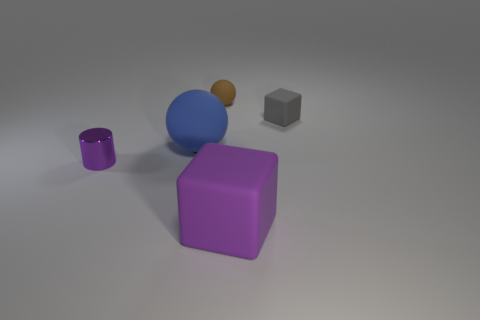Are the large purple cube and the small purple thing made of the same material?
Your answer should be compact. No. What number of other objects are the same size as the brown rubber ball?
Make the answer very short. 2. There is a thing in front of the small thing that is left of the brown object; are there any small objects on the left side of it?
Your response must be concise. Yes. Do the big thing behind the small purple object and the large purple block have the same material?
Ensure brevity in your answer.  Yes. What color is the other matte thing that is the same shape as the purple rubber thing?
Offer a very short reply. Gray. Are there any other things that have the same shape as the tiny purple metallic object?
Ensure brevity in your answer.  No. Are there an equal number of tiny blocks left of the large purple matte thing and large blue rubber things?
Your answer should be compact. No. There is a large blue thing; are there any small things to the left of it?
Your response must be concise. Yes. How big is the matte cube behind the purple object that is on the left side of the large rubber object in front of the cylinder?
Make the answer very short. Small. There is a large thing on the right side of the large rubber ball; does it have the same shape as the small matte object to the right of the large purple block?
Provide a succinct answer. Yes. 